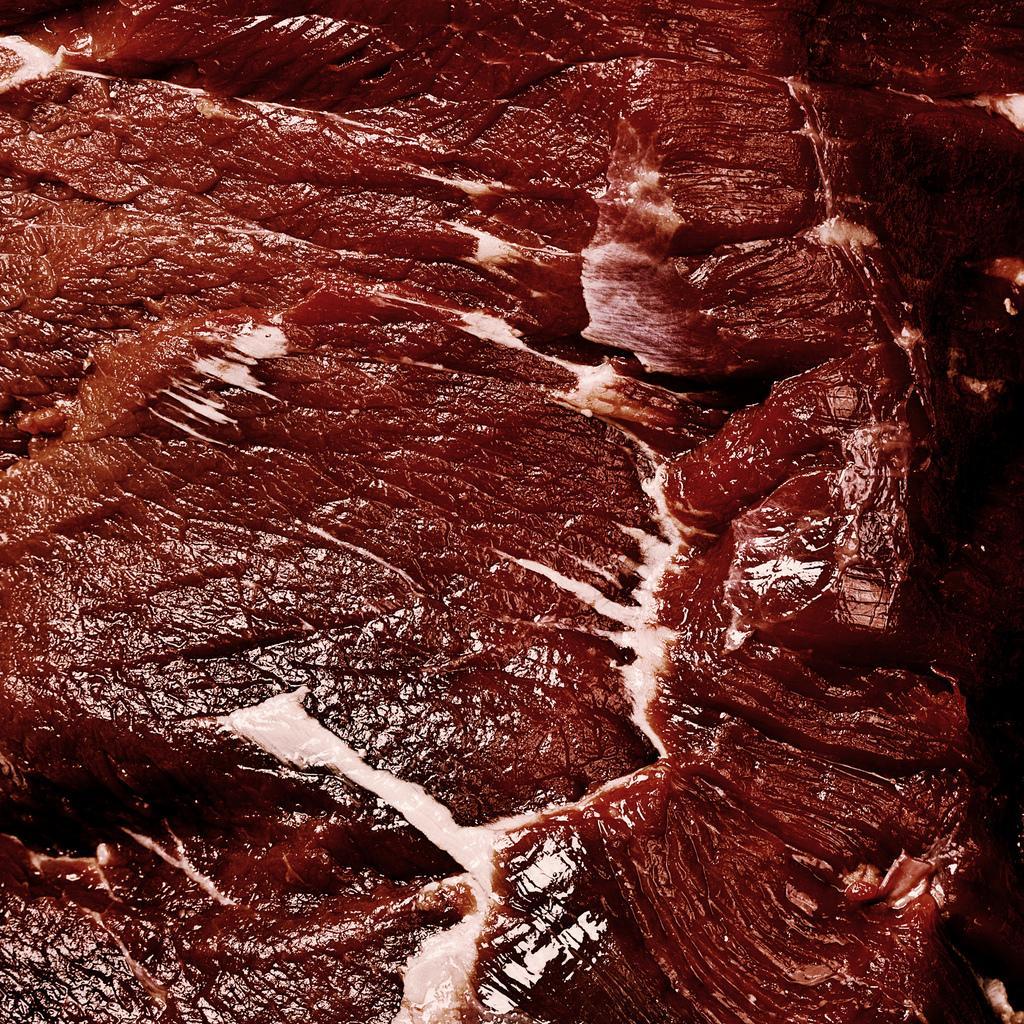How would you summarize this image in a sentence or two? This image consist of meat which is red in colour. 